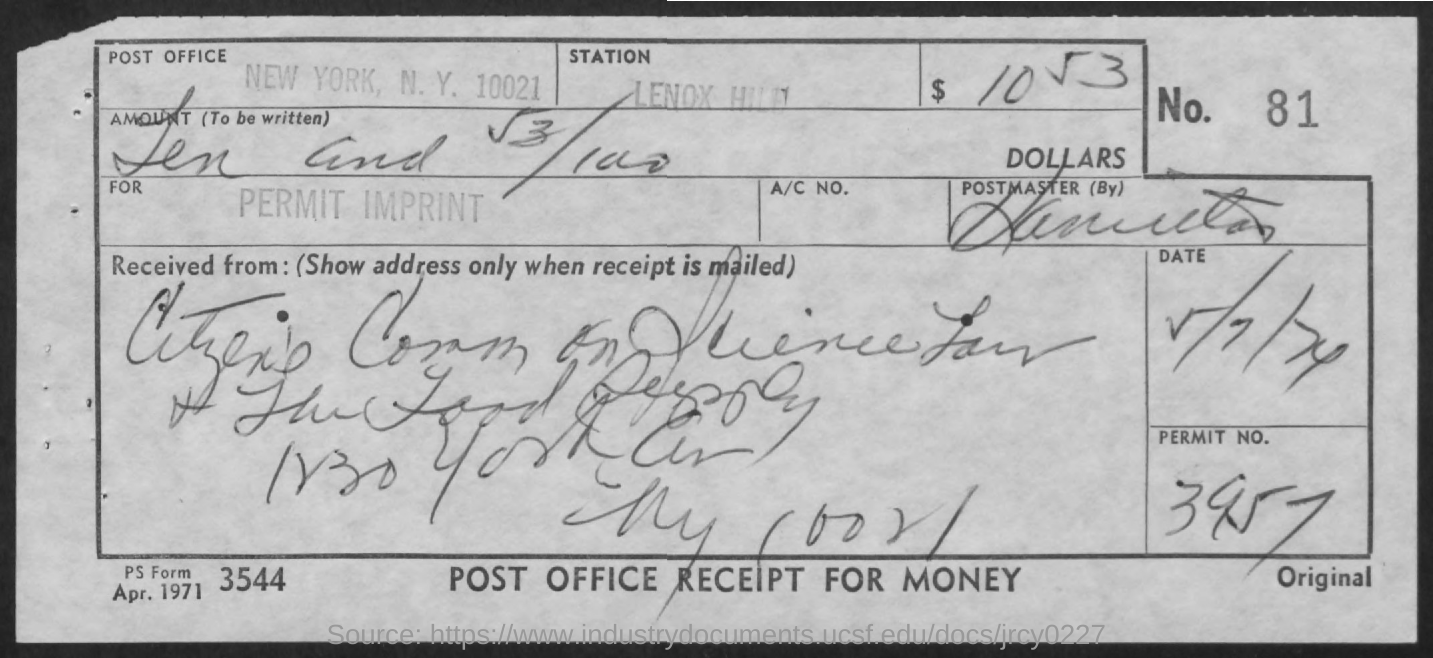Point out several critical features in this image. The permit number is 3957. The number is 81. Please provide the form number, which is 3544. 